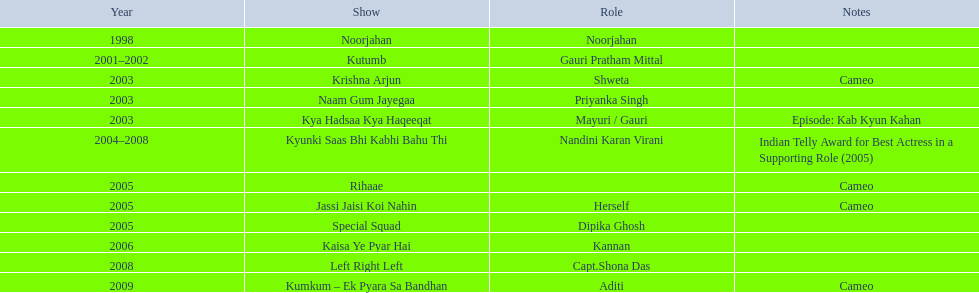Parse the full table. {'header': ['Year', 'Show', 'Role', 'Notes'], 'rows': [['1998', 'Noorjahan', 'Noorjahan', ''], ['2001–2002', 'Kutumb', 'Gauri Pratham Mittal', ''], ['2003', 'Krishna Arjun', 'Shweta', 'Cameo'], ['2003', 'Naam Gum Jayegaa', 'Priyanka Singh', ''], ['2003', 'Kya Hadsaa Kya Haqeeqat', 'Mayuri / Gauri', 'Episode: Kab Kyun Kahan'], ['2004–2008', 'Kyunki Saas Bhi Kabhi Bahu Thi', 'Nandini Karan Virani', 'Indian Telly Award for Best Actress in a Supporting Role (2005)'], ['2005', 'Rihaae', '', 'Cameo'], ['2005', 'Jassi Jaisi Koi Nahin', 'Herself', 'Cameo'], ['2005', 'Special Squad', 'Dipika Ghosh', ''], ['2006', 'Kaisa Ye Pyar Hai', 'Kannan', ''], ['2008', 'Left Right Left', 'Capt.Shona Das', ''], ['2009', 'Kumkum – Ek Pyara Sa Bandhan', 'Aditi', 'Cameo']]} What are all the programs? Noorjahan, Kutumb, Krishna Arjun, Naam Gum Jayegaa, Kya Hadsaa Kya Haqeeqat, Kyunki Saas Bhi Kabhi Bahu Thi, Rihaae, Jassi Jaisi Koi Nahin, Special Squad, Kaisa Ye Pyar Hai, Left Right Left, Kumkum – Ek Pyara Sa Bandhan. When were their initial airings? 1998, 2001–2002, 2003, 2003, 2003, 2004–2008, 2005, 2005, 2005, 2006, 2008, 2009. What records exist for the shows from 2005? Cameo, Cameo. Apart from rihaee, what is the other show in which gauri had a brief appearance? Jassi Jaisi Koi Nahin. 